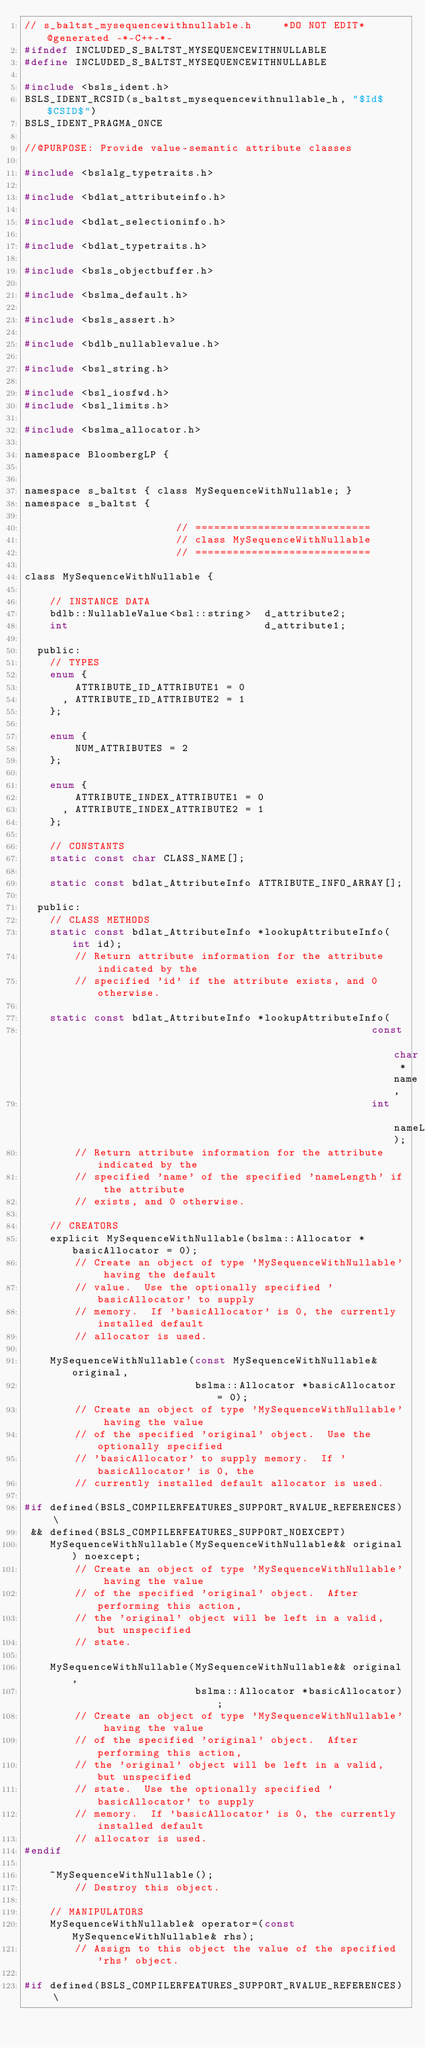Convert code to text. <code><loc_0><loc_0><loc_500><loc_500><_C_>// s_baltst_mysequencewithnullable.h     *DO NOT EDIT*     @generated -*-C++-*-
#ifndef INCLUDED_S_BALTST_MYSEQUENCEWITHNULLABLE
#define INCLUDED_S_BALTST_MYSEQUENCEWITHNULLABLE

#include <bsls_ident.h>
BSLS_IDENT_RCSID(s_baltst_mysequencewithnullable_h, "$Id$ $CSID$")
BSLS_IDENT_PRAGMA_ONCE

//@PURPOSE: Provide value-semantic attribute classes

#include <bslalg_typetraits.h>

#include <bdlat_attributeinfo.h>

#include <bdlat_selectioninfo.h>

#include <bdlat_typetraits.h>

#include <bsls_objectbuffer.h>

#include <bslma_default.h>

#include <bsls_assert.h>

#include <bdlb_nullablevalue.h>

#include <bsl_string.h>

#include <bsl_iosfwd.h>
#include <bsl_limits.h>

#include <bslma_allocator.h>

namespace BloombergLP {


namespace s_baltst { class MySequenceWithNullable; }
namespace s_baltst {

                        // ============================
                        // class MySequenceWithNullable
                        // ============================

class MySequenceWithNullable {

    // INSTANCE DATA
    bdlb::NullableValue<bsl::string>  d_attribute2;
    int                               d_attribute1;

  public:
    // TYPES
    enum {
        ATTRIBUTE_ID_ATTRIBUTE1 = 0
      , ATTRIBUTE_ID_ATTRIBUTE2 = 1
    };

    enum {
        NUM_ATTRIBUTES = 2
    };

    enum {
        ATTRIBUTE_INDEX_ATTRIBUTE1 = 0
      , ATTRIBUTE_INDEX_ATTRIBUTE2 = 1
    };

    // CONSTANTS
    static const char CLASS_NAME[];

    static const bdlat_AttributeInfo ATTRIBUTE_INFO_ARRAY[];

  public:
    // CLASS METHODS
    static const bdlat_AttributeInfo *lookupAttributeInfo(int id);
        // Return attribute information for the attribute indicated by the
        // specified 'id' if the attribute exists, and 0 otherwise.

    static const bdlat_AttributeInfo *lookupAttributeInfo(
                                                       const char *name,
                                                       int         nameLength);
        // Return attribute information for the attribute indicated by the
        // specified 'name' of the specified 'nameLength' if the attribute
        // exists, and 0 otherwise.

    // CREATORS
    explicit MySequenceWithNullable(bslma::Allocator *basicAllocator = 0);
        // Create an object of type 'MySequenceWithNullable' having the default
        // value.  Use the optionally specified 'basicAllocator' to supply
        // memory.  If 'basicAllocator' is 0, the currently installed default
        // allocator is used.

    MySequenceWithNullable(const MySequenceWithNullable& original,
                           bslma::Allocator *basicAllocator = 0);
        // Create an object of type 'MySequenceWithNullable' having the value
        // of the specified 'original' object.  Use the optionally specified
        // 'basicAllocator' to supply memory.  If 'basicAllocator' is 0, the
        // currently installed default allocator is used.

#if defined(BSLS_COMPILERFEATURES_SUPPORT_RVALUE_REFERENCES) \
 && defined(BSLS_COMPILERFEATURES_SUPPORT_NOEXCEPT)
    MySequenceWithNullable(MySequenceWithNullable&& original) noexcept;
        // Create an object of type 'MySequenceWithNullable' having the value
        // of the specified 'original' object.  After performing this action,
        // the 'original' object will be left in a valid, but unspecified
        // state.

    MySequenceWithNullable(MySequenceWithNullable&& original,
                           bslma::Allocator *basicAllocator);
        // Create an object of type 'MySequenceWithNullable' having the value
        // of the specified 'original' object.  After performing this action,
        // the 'original' object will be left in a valid, but unspecified
        // state.  Use the optionally specified 'basicAllocator' to supply
        // memory.  If 'basicAllocator' is 0, the currently installed default
        // allocator is used.
#endif

    ~MySequenceWithNullable();
        // Destroy this object.

    // MANIPULATORS
    MySequenceWithNullable& operator=(const MySequenceWithNullable& rhs);
        // Assign to this object the value of the specified 'rhs' object.

#if defined(BSLS_COMPILERFEATURES_SUPPORT_RVALUE_REFERENCES) \</code> 